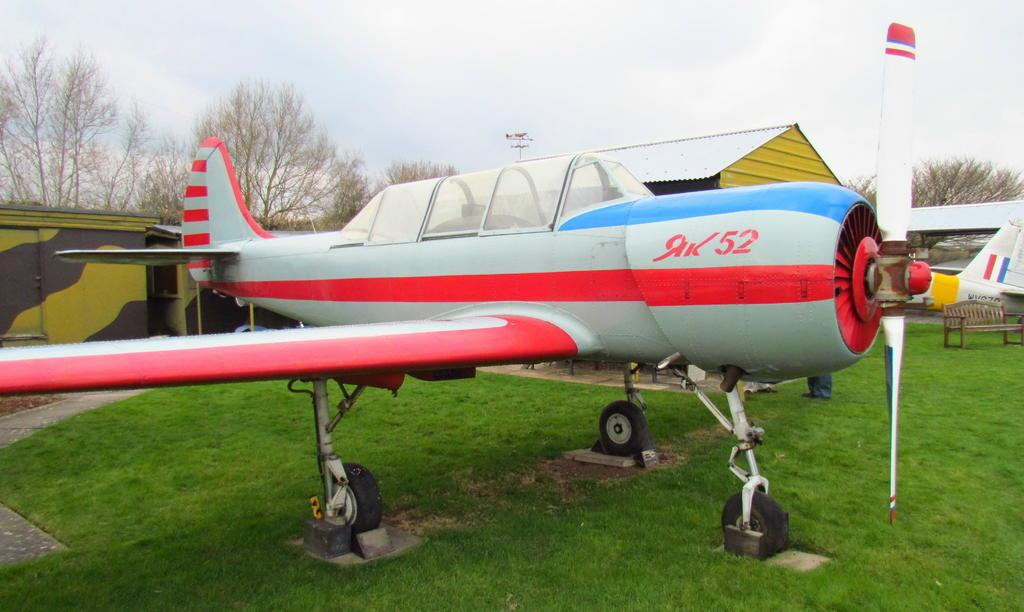<image>
Provide a brief description of the given image. A plane with the number 52 written on the side 